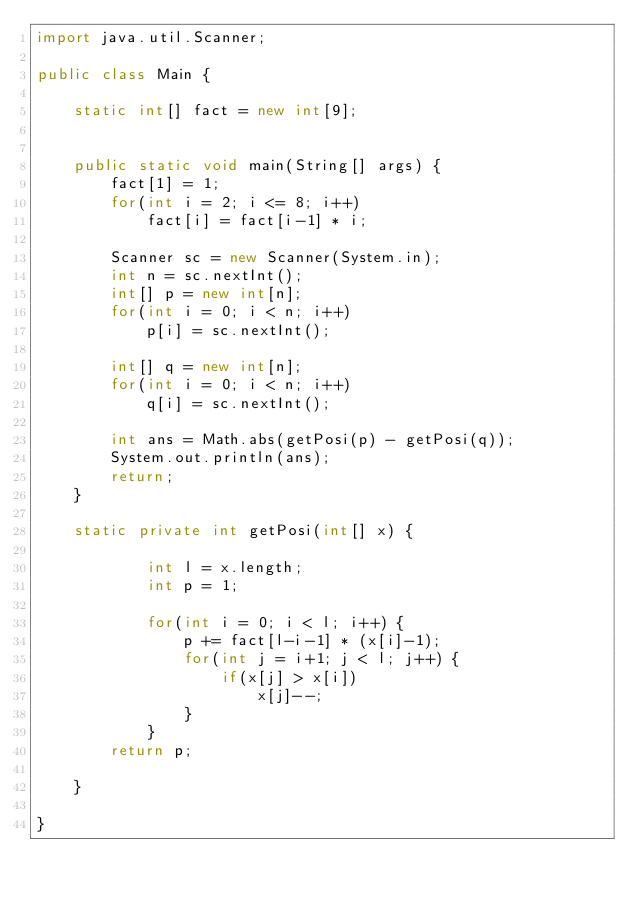Convert code to text. <code><loc_0><loc_0><loc_500><loc_500><_Java_>import java.util.Scanner;

public class Main {

	static int[] fact = new int[9];


	public static void main(String[] args) {
		fact[1] = 1;
		for(int i = 2; i <= 8; i++)
			fact[i] = fact[i-1] * i;

		Scanner sc = new Scanner(System.in);
		int n = sc.nextInt();
		int[] p = new int[n];
		for(int i = 0; i < n; i++)
			p[i] = sc.nextInt();

		int[] q = new int[n];
		for(int i = 0; i < n; i++)
			q[i] = sc.nextInt();

		int ans = Math.abs(getPosi(p) - getPosi(q));
		System.out.println(ans);
        return;
    }

	static private int getPosi(int[] x) {

			int l = x.length;
			int p = 1;

			for(int i = 0; i < l; i++) {
				p += fact[l-i-1] * (x[i]-1);
				for(int j = i+1; j < l; j++) {
					if(x[j] > x[i])
						x[j]--;
				}
			}
		return p;

	}

}

</code> 